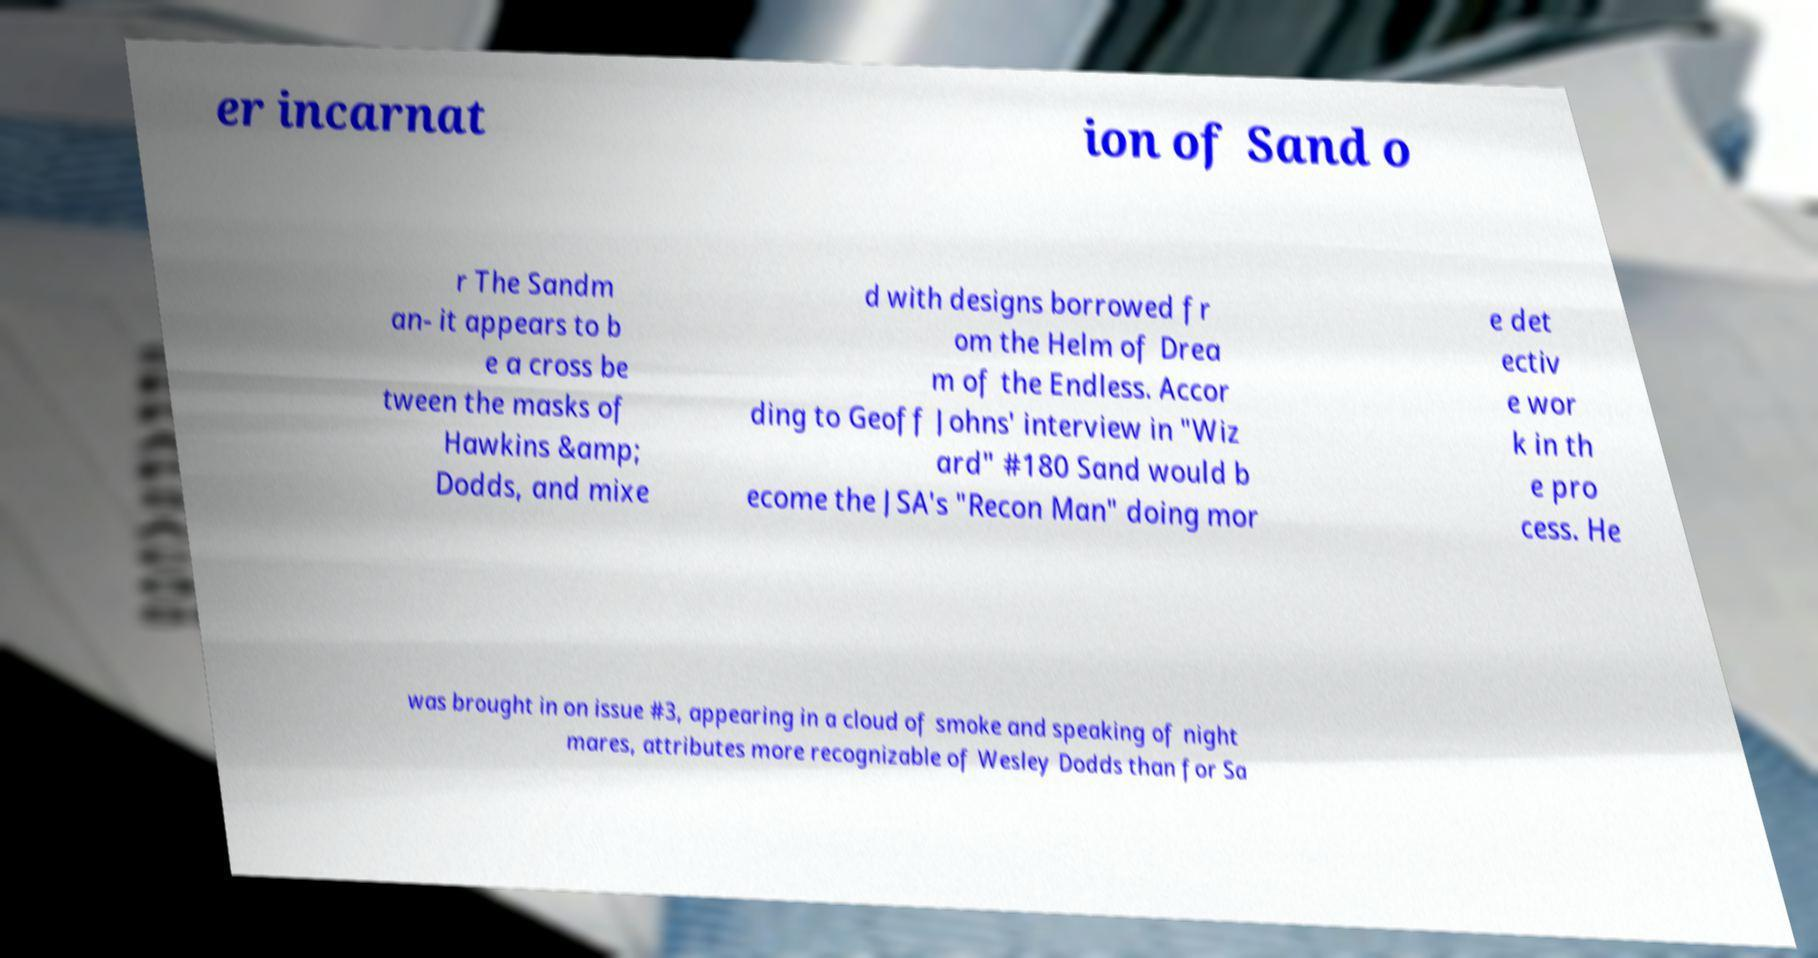Can you accurately transcribe the text from the provided image for me? er incarnat ion of Sand o r The Sandm an- it appears to b e a cross be tween the masks of Hawkins &amp; Dodds, and mixe d with designs borrowed fr om the Helm of Drea m of the Endless. Accor ding to Geoff Johns' interview in "Wiz ard" #180 Sand would b ecome the JSA's "Recon Man" doing mor e det ectiv e wor k in th e pro cess. He was brought in on issue #3, appearing in a cloud of smoke and speaking of night mares, attributes more recognizable of Wesley Dodds than for Sa 